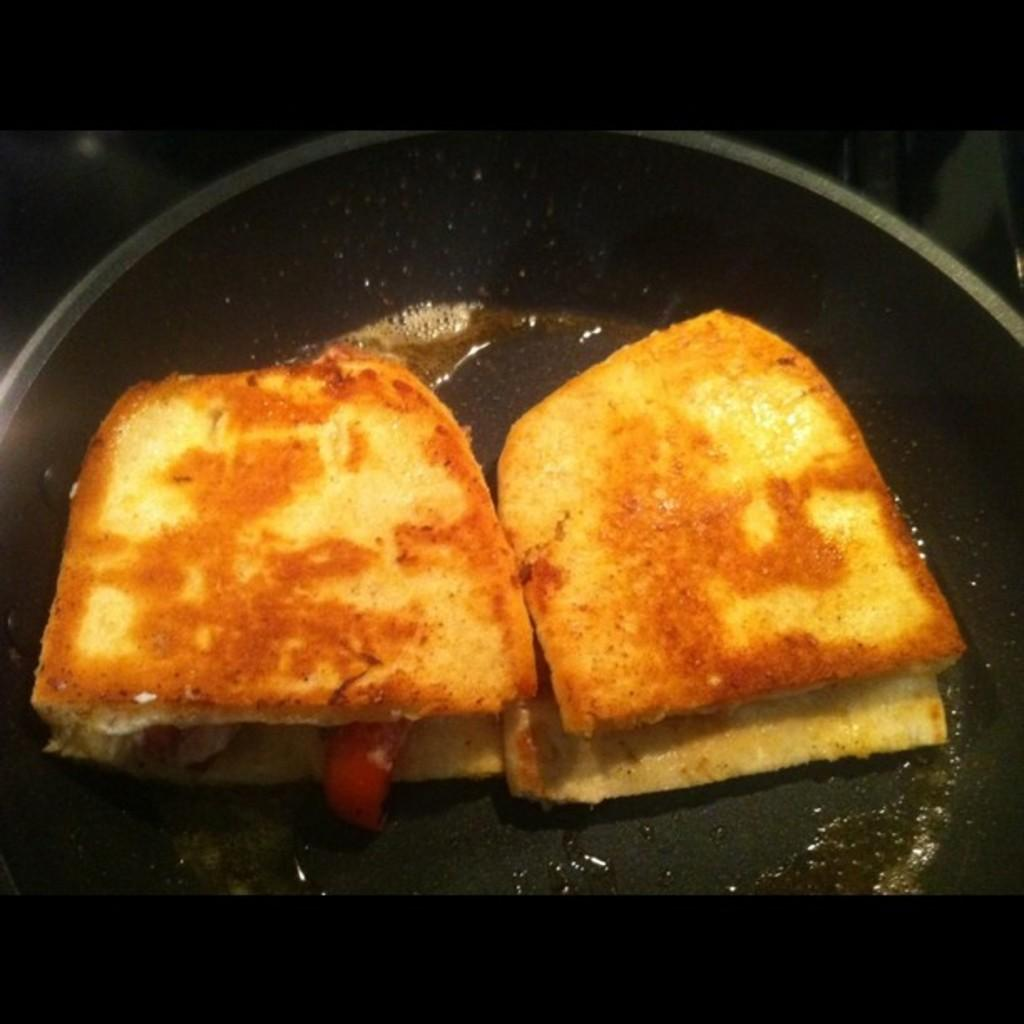What type of food is visible in the image? There are two bread toasts in the image. Where are the bread toasts located? The bread toasts are in a pan. What type of girl is depicted on the marble surface in the image? There is no girl or marble surface present in the image; it only features two bread toasts in a pan. 